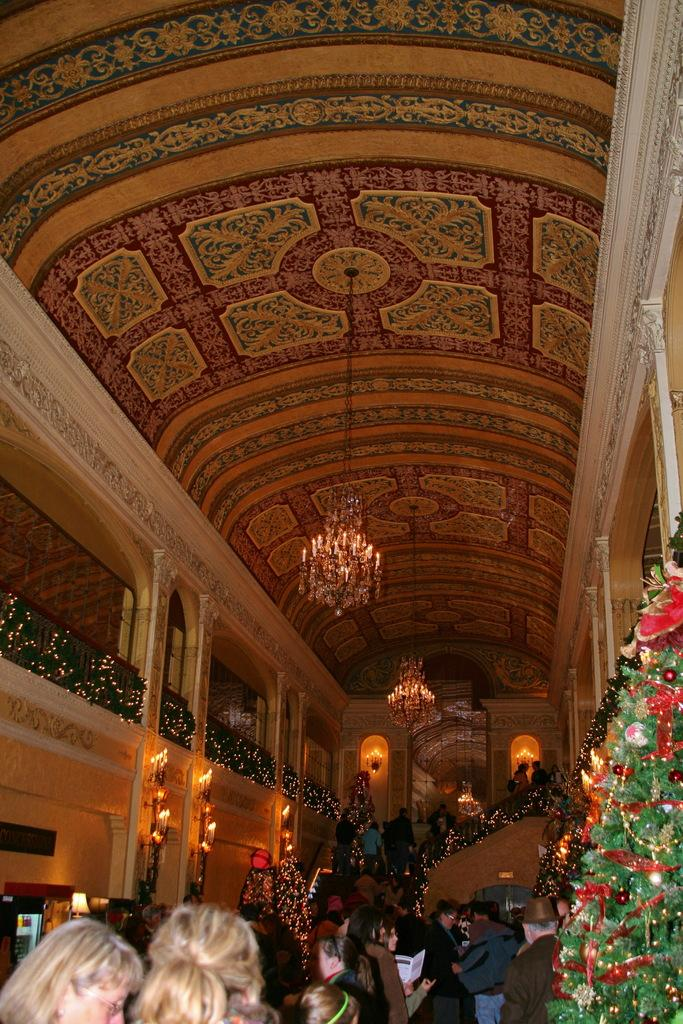Who or what can be seen in the image? There are people in the image. What type of decorative objects are present in the image? There are plants with lights in the image. What architectural feature is visible on the roof in the image? There are lamps on the roof in the image. How many goldfish are swimming in the image? There are no goldfish present in the image. What type of camera is being used to take the picture? The facts provided do not mention a camera, so it cannot be determined from the image. 